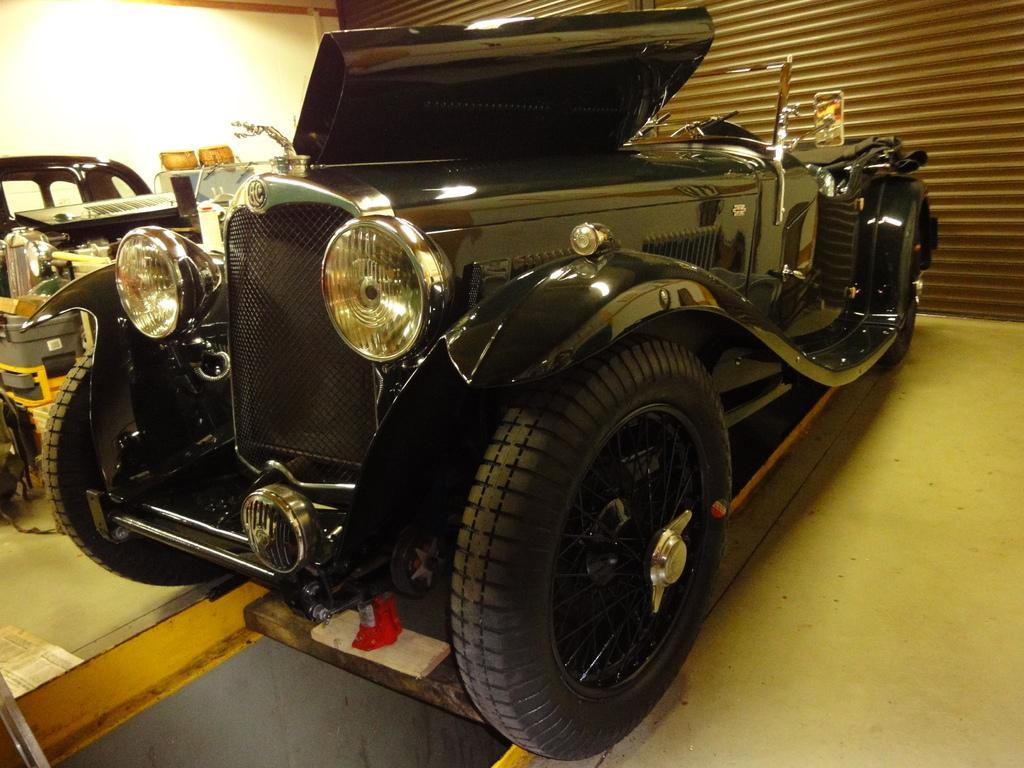Can you describe this image briefly? In this image we can see a few vehicles, in front of the vehicles there is a shutter, on the left side we can see a wall. 